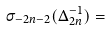Convert formula to latex. <formula><loc_0><loc_0><loc_500><loc_500>\sigma _ { - 2 n - 2 } ( \Delta _ { 2 n } ^ { - 1 } ) =</formula> 